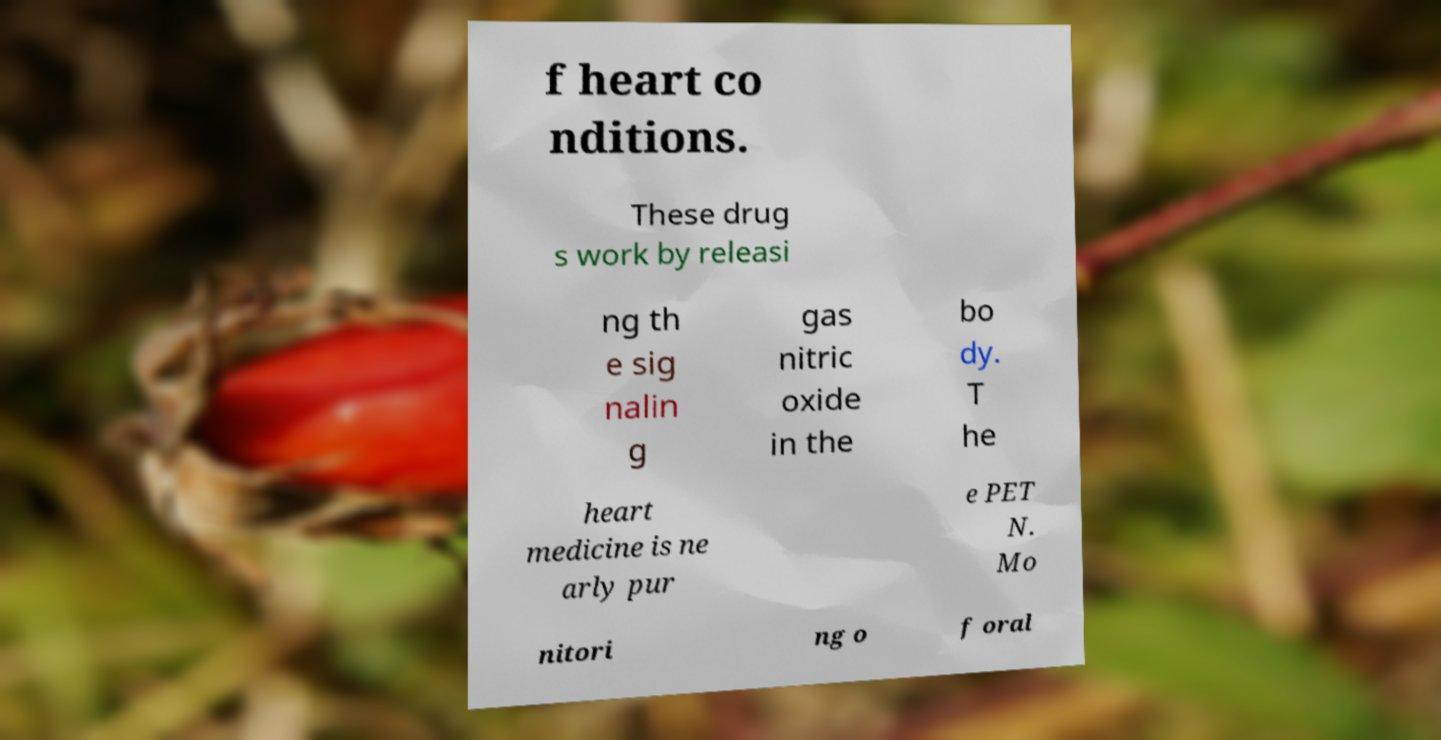I need the written content from this picture converted into text. Can you do that? f heart co nditions. These drug s work by releasi ng th e sig nalin g gas nitric oxide in the bo dy. T he heart medicine is ne arly pur e PET N. Mo nitori ng o f oral 